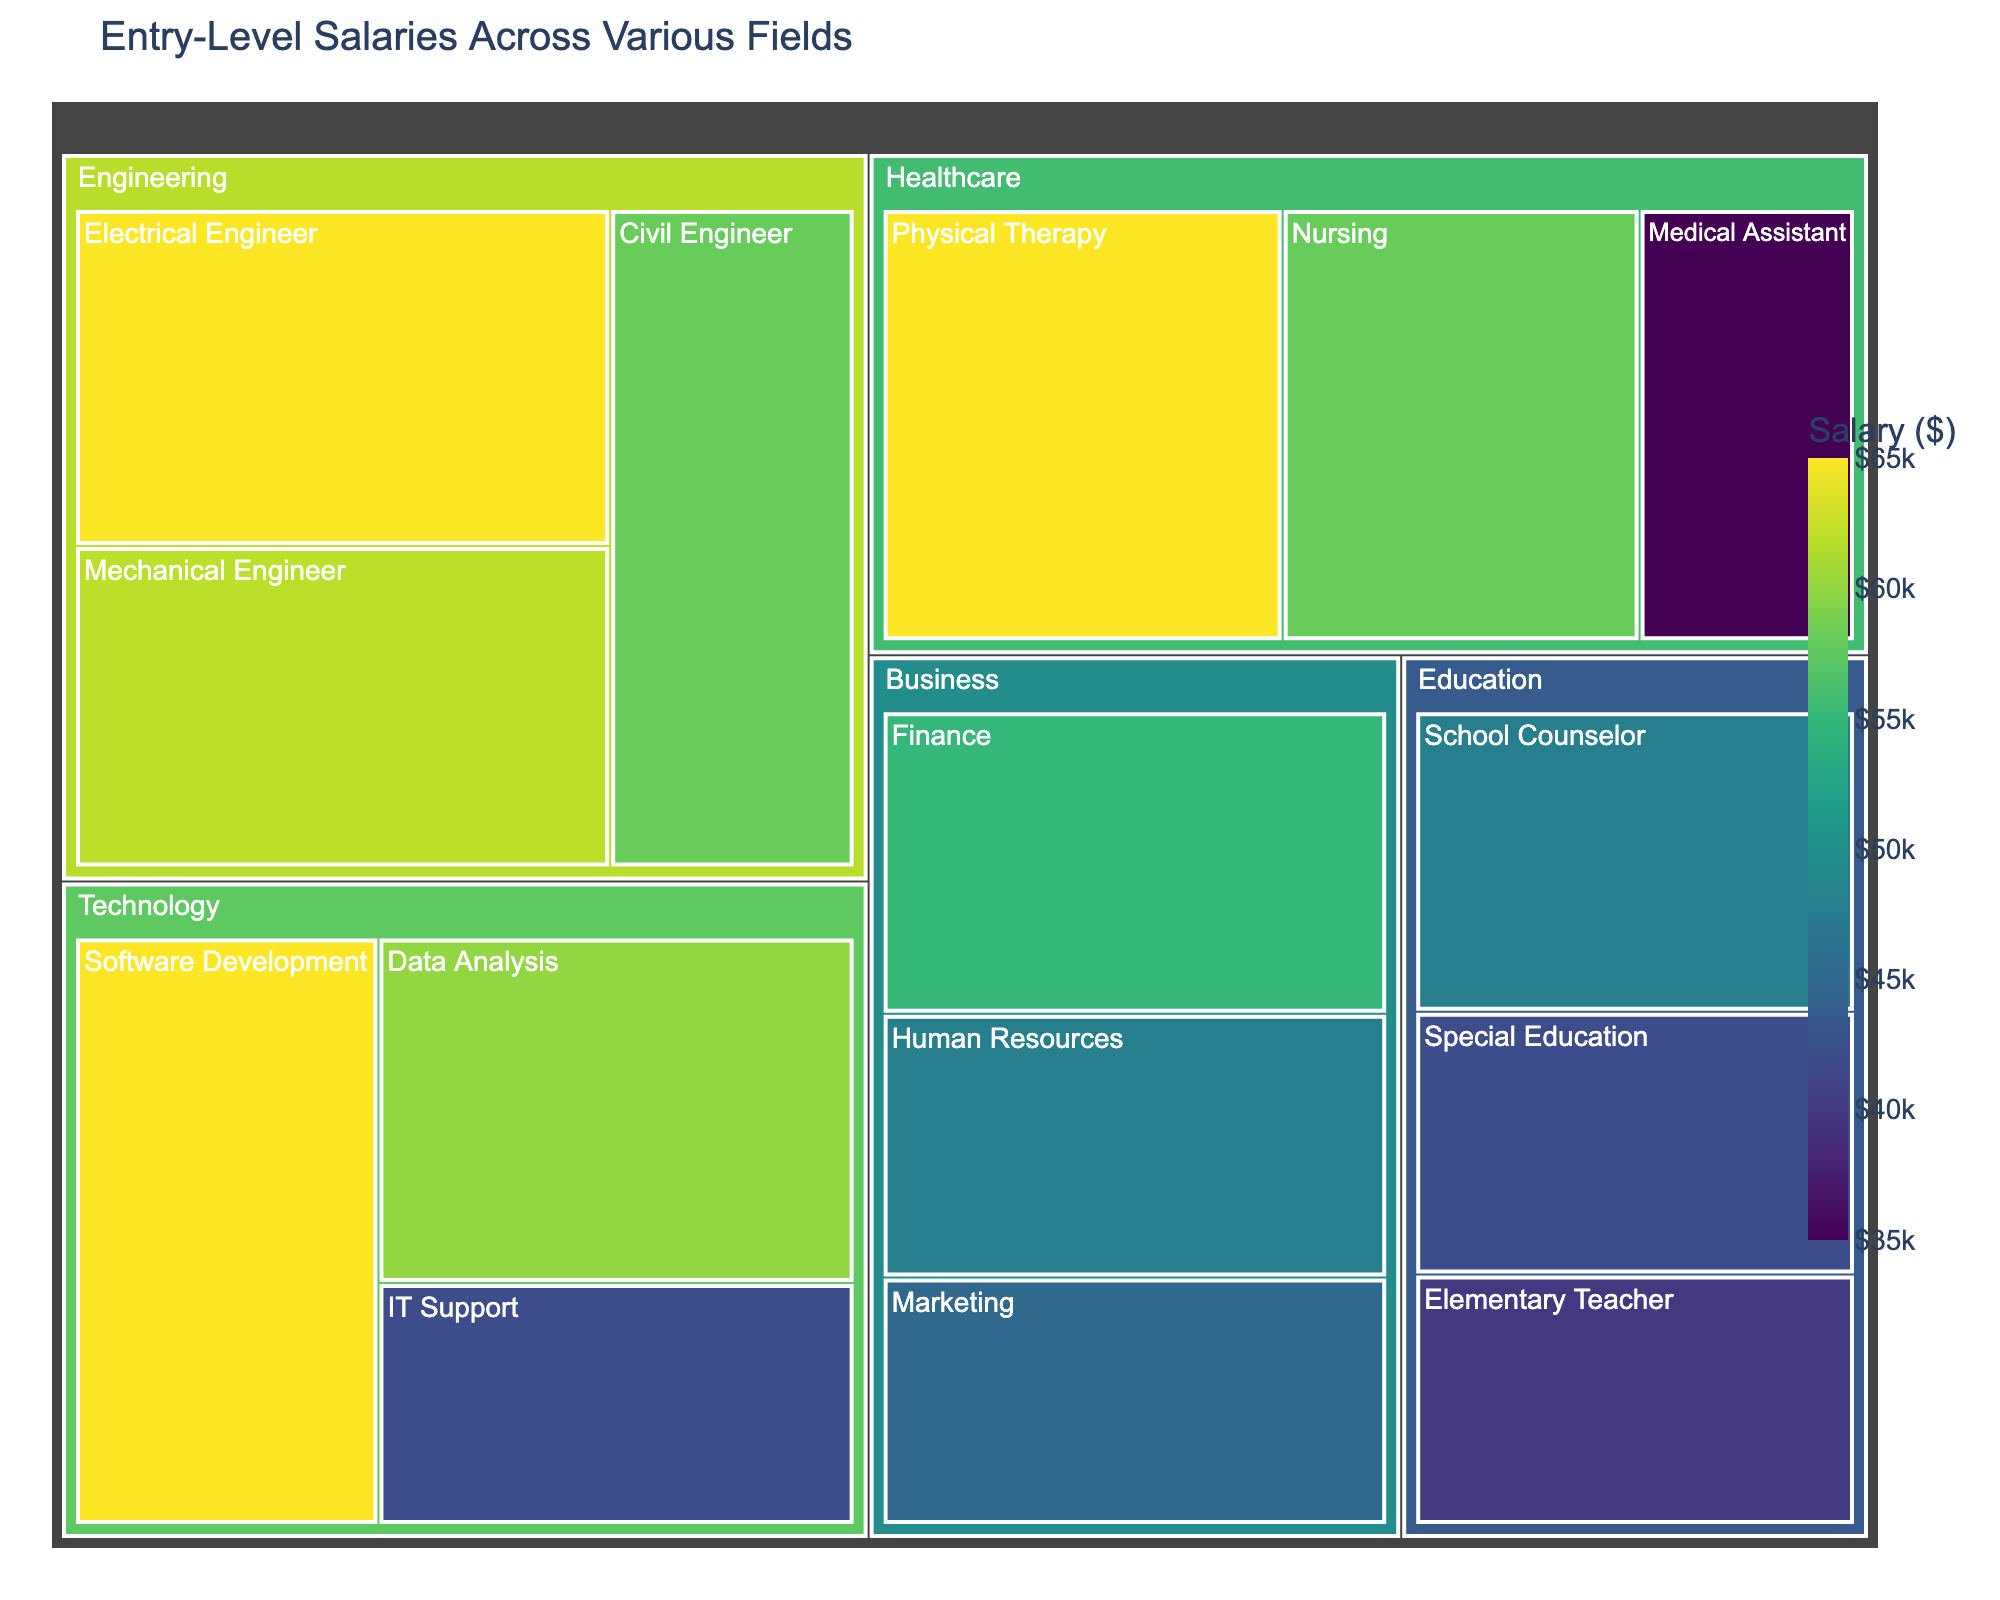What is the highest salary displayed in the treemap? The highest salary can be found by looking at the subfields in the treemap and locating the one with the largest value. From the figure, Software Development and Electrical Engineer both have salaries of $65,000.
Answer: $65,000 Which field has the most subfields listed? To determine this, count the number of subfields for each field. The field 'Business' has Marketing, Finance, and Human Resources, totaling 3 subfields.
Answer: Business What is the average salary for subfields in the Technology field? First, identify the subfields and their salaries in Technology: Software Development ($65,000), IT Support ($42,000), Data Analysis ($60,000). Calculate the average salary by adding these amounts and dividing by the number of subfields: (65000 + 42000 + 60000)/3 = 167000/3 = 55666.67.
Answer: $55,667 How much more is the highest salary compared to the lowest salary in the treemap? Find the highest salary ($65,000) and the lowest salary ($35,000). Subtract the lowest from the highest to determine the difference: 65000 - 35000 = 30000.
Answer: $30,000 Which subfield has the lowest salary, and what is it? Locate the smallest value in the treemap, which corresponds to the Medical Assistant subfield with a salary of $35,000.
Answer: Medical Assistant, $35,000 Among the subfields in Healthcare, which one has the highest salary? Identify the salaries in Healthcare: Nursing ($58,000), Medical Assistant ($35,000), Physical Therapy ($65,000). Determine which is the highest, which is Physical Therapy with $65,000.
Answer: Physical Therapy Is the average salary of subfields in Engineering higher or lower than that in Healthcare? Calculate the average salary for both fields. Engineering: (62000 + 58000 + 65000)/3 = $61,333. Healthcare: (58000 + 35000 + 65000)/3 = $53,000. Compare these averages.
Answer: Higher in Engineering What is the total combined salary of all subfields in the Education field? Add the salaries of subfields in Education: Elementary Teacher ($40,000), Special Education ($42,000), School Counselor ($48,000). The sum is 40000 + 42000 + 48000 = $130,000.
Answer: $130,000 Which subfield in Business has the highest salary? Compare the salaries within the Business subfields: Marketing ($45,000), Finance ($55,000), Human Resources ($48,000). Finance has the highest salary at $55,000.
Answer: Finance What is the salary difference between the lowest salary in Technology and the highest salary in Education? Identify the lowest salary in Technology (IT Support, $42,000) and the highest in Education (School Counselor, $48,000). Calculate the difference: 48000 - 42000 = 6000.
Answer: $6,000 